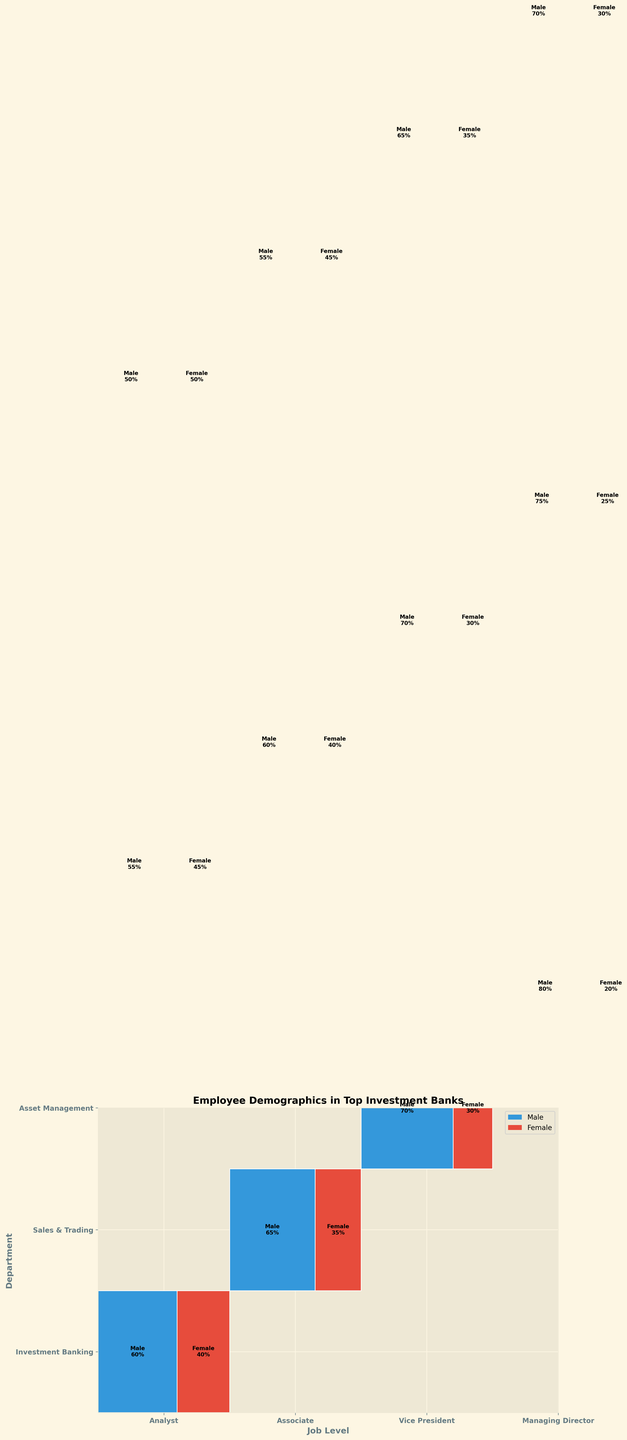What's the title of the figure? The title of the figure is usually displayed at the top of the plot. Here, it reads "Employee Demographics in Top Investment Banks."
Answer: Employee Demographics in Top Investment Banks What do the x-axis labels represent? The x-axis labels represent different job levels in the investment banks. They are "Analyst," "Associate," "Vice President," and "Managing Director."
Answer: Job levels What are the color codes used to distinguish gender? The plot uses two distinct colors to represent gender: blue for Male and red for Female.
Answer: blue and red Which department has an equal percentage of male and female Analysts? By examining the plot, we can see that in the "Asset Management" department, the percentage of male and female Analysts is both 50%.
Answer: Asset Management How does the gender distribution change from Analysts to Managing Directors in Sales & Trading? By observing the plot for Sales & Trading, Analysts have 55% Male and 45% Female, Associates have 60% Male and 40% Female, Vice Presidents have 70% Male and 30% Female, and Managing Directors have 75% Male and 25% Female. The percentage of males increases, and the percentage of females decreases as the job level increases.
Answer: Males increase, Females decrease Which job level in Investment Banking has the highest percentage of females? Examining the Investment Banking section, Analysts have 40%, Associates have 35%, Vice Presidents have 30%, and Managing Directors have 20%. Therefore, Analysts have the highest percentage of females.
Answer: Analysts Compare the percentage of males in Managing Director positions across all departments. Which department has the smallest percentage? By comparing the Managing Director positions: Investment Banking has 80%, Sales & Trading has 75%, and Asset Management has 70%. Asset Management has the smallest percentage of males.
Answer: Asset Management What is the combined percentage of female Vice Presidents in Investment Banking and Sales & Trading? The percentage of females is 30% in both Investment Banking and Sales & Trading for Vice Presidents. Combined, this is 30% + 30% = 60%.
Answer: 60% In which department does the gender balance (Male vs. Female) stay most consistent across all job levels? Looking at the plot, Asset Management shows the most consistent gender distribution across all job levels, with percentages changing minimally compared to other departments.
Answer: Asset Management How many job levels are evaluated in each department? There are four job levels evaluated in each department. These are "Analyst," "Associate," "Vice President," and "Managing Director."
Answer: 4 